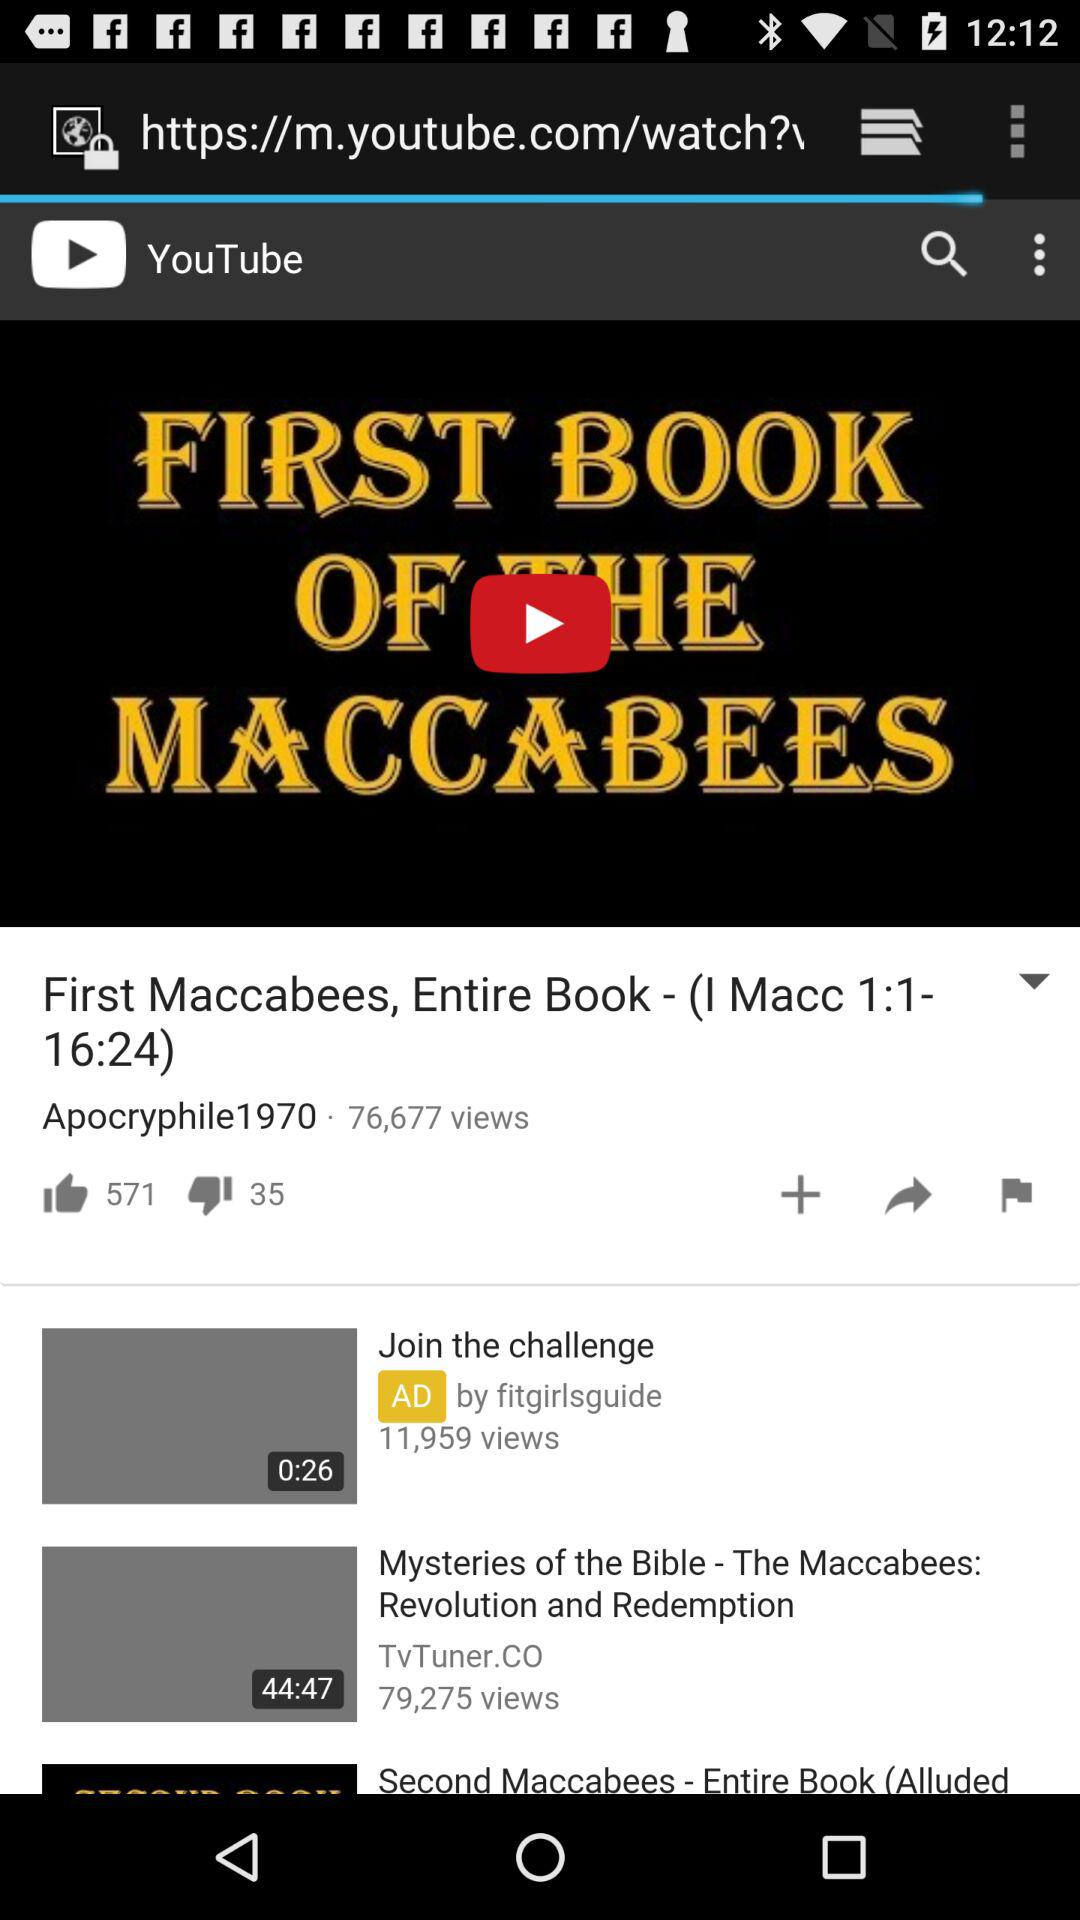What is the title of the current video in the player? The title of the current video in the player is "First Maccabees, Entire Book - (I Macc 1:1-16:24)". 